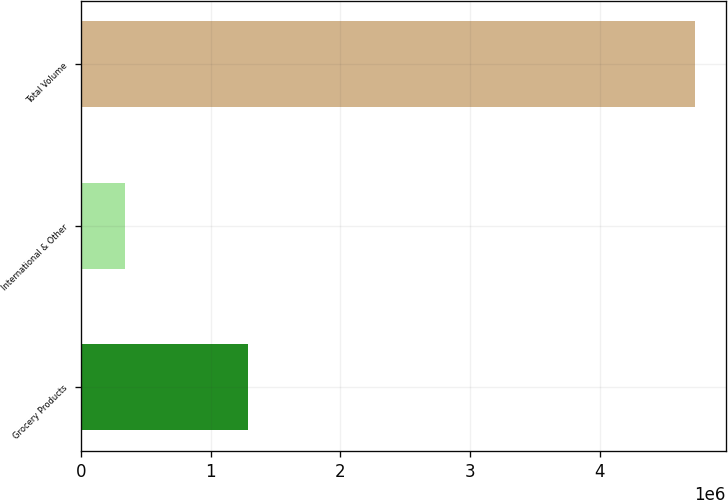<chart> <loc_0><loc_0><loc_500><loc_500><bar_chart><fcel>Grocery Products<fcel>International & Other<fcel>Total Volume<nl><fcel>1.28349e+06<fcel>339296<fcel>4.73728e+06<nl></chart> 